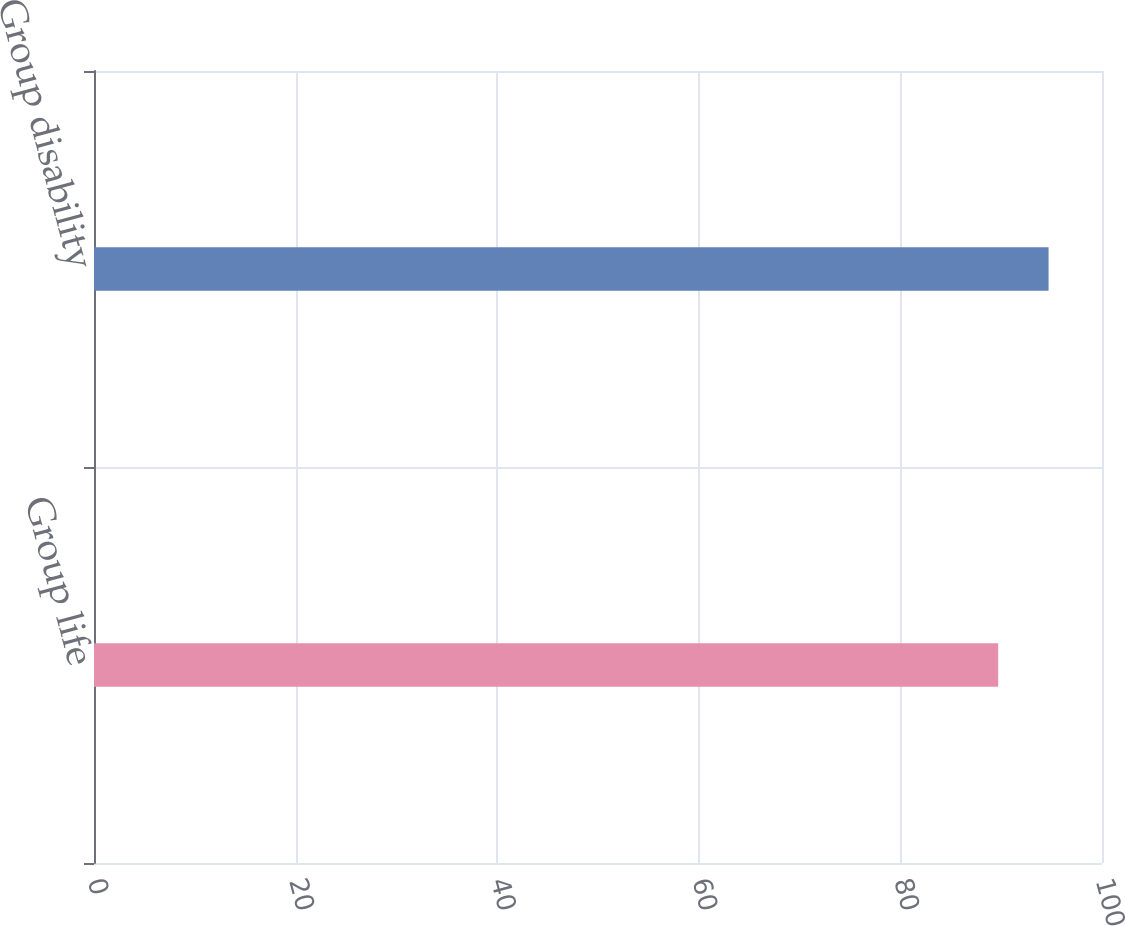Convert chart to OTSL. <chart><loc_0><loc_0><loc_500><loc_500><bar_chart><fcel>Group life<fcel>Group disability<nl><fcel>89.7<fcel>94.7<nl></chart> 